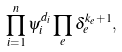Convert formula to latex. <formula><loc_0><loc_0><loc_500><loc_500>\prod _ { i = 1 } ^ { n } \psi _ { i } ^ { d _ { i } } \prod _ { e } \delta _ { e } ^ { k _ { e } + 1 } ,</formula> 